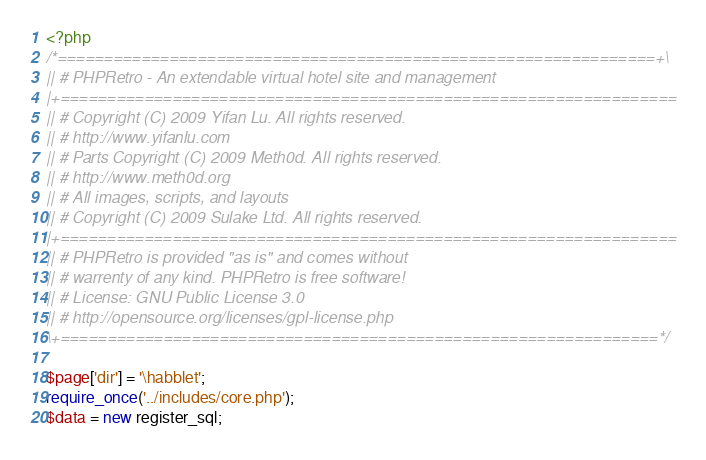<code> <loc_0><loc_0><loc_500><loc_500><_PHP_><?php
/*================================================================+\
|| # PHPRetro - An extendable virtual hotel site and management
|+==================================================================
|| # Copyright (C) 2009 Yifan Lu. All rights reserved.
|| # http://www.yifanlu.com
|| # Parts Copyright (C) 2009 Meth0d. All rights reserved.
|| # http://www.meth0d.org
|| # All images, scripts, and layouts
|| # Copyright (C) 2009 Sulake Ltd. All rights reserved.
|+==================================================================
|| # PHPRetro is provided "as is" and comes without
|| # warrenty of any kind. PHPRetro is free software!
|| # License: GNU Public License 3.0
|| # http://opensource.org/licenses/gpl-license.php
\+================================================================*/

$page['dir'] = '\habblet';
require_once('../includes/core.php');
$data = new register_sql;</code> 